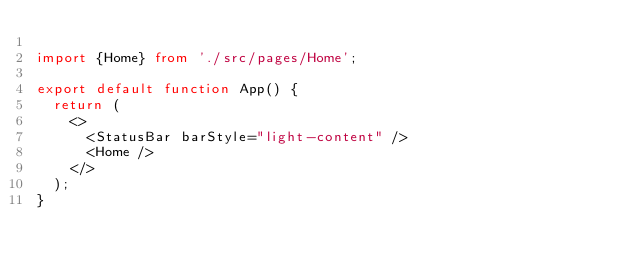<code> <loc_0><loc_0><loc_500><loc_500><_TypeScript_>
import {Home} from './src/pages/Home';

export default function App() {
  return (
    <>
      <StatusBar barStyle="light-content" />
      <Home />
    </>
  );
}
</code> 